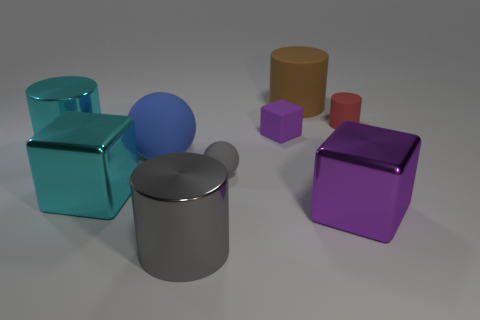Subtract all red matte cylinders. How many cylinders are left? 3 Subtract 1 cylinders. How many cylinders are left? 3 Subtract all gray cylinders. How many cylinders are left? 3 Subtract all purple cylinders. Subtract all red balls. How many cylinders are left? 4 Subtract all cubes. How many objects are left? 6 Add 7 large cylinders. How many large cylinders are left? 10 Add 6 large purple metallic blocks. How many large purple metallic blocks exist? 7 Subtract 0 brown balls. How many objects are left? 9 Subtract all large purple shiny cylinders. Subtract all large blue matte spheres. How many objects are left? 8 